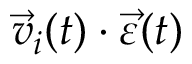<formula> <loc_0><loc_0><loc_500><loc_500>\ V e c { v } _ { i } ( t ) \cdot \ V e c { \varepsilon } ( t )</formula> 